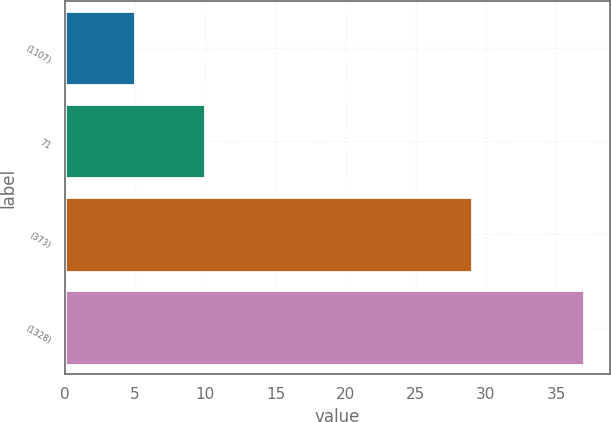<chart> <loc_0><loc_0><loc_500><loc_500><bar_chart><fcel>(1107)<fcel>71<fcel>(373)<fcel>(1328)<nl><fcel>5<fcel>10<fcel>29<fcel>37<nl></chart> 